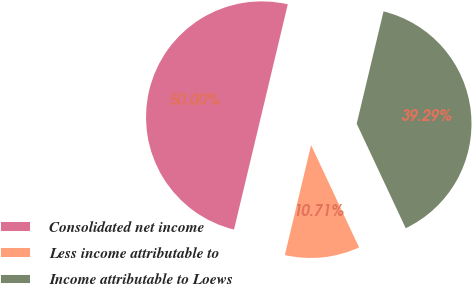Convert chart to OTSL. <chart><loc_0><loc_0><loc_500><loc_500><pie_chart><fcel>Consolidated net income<fcel>Less income attributable to<fcel>Income attributable to Loews<nl><fcel>50.0%<fcel>10.71%<fcel>39.29%<nl></chart> 